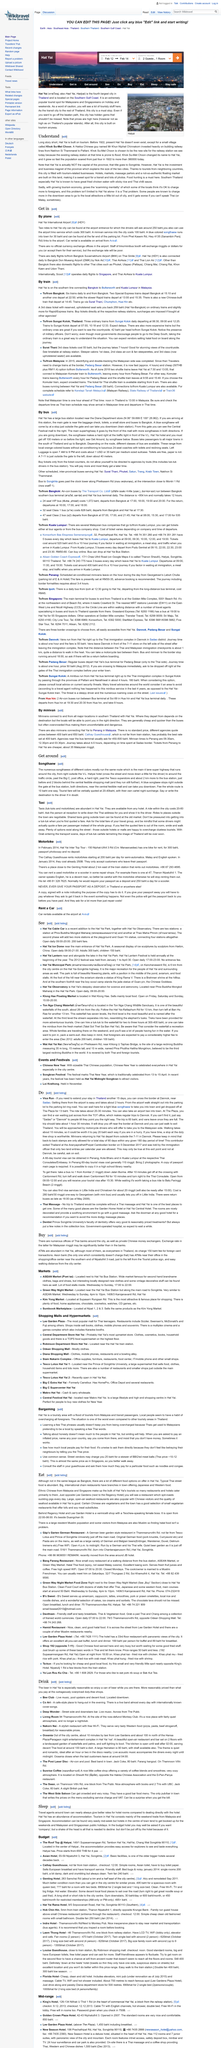Give some essential details in this illustration. The Bee Club offers a unique and enjoyable experience, featuring live music, an upstairs swimming pool, and high-quality cuisine. Yes, a songthaew is a means to get around the city. Hat Yai, a city located in the southern gulf coast region of Thailand, can be found in the south of the country. The main super highway has a total of 4 lanes, each accommodating traffic in a separate direction. The text contains three hotels that are named. 